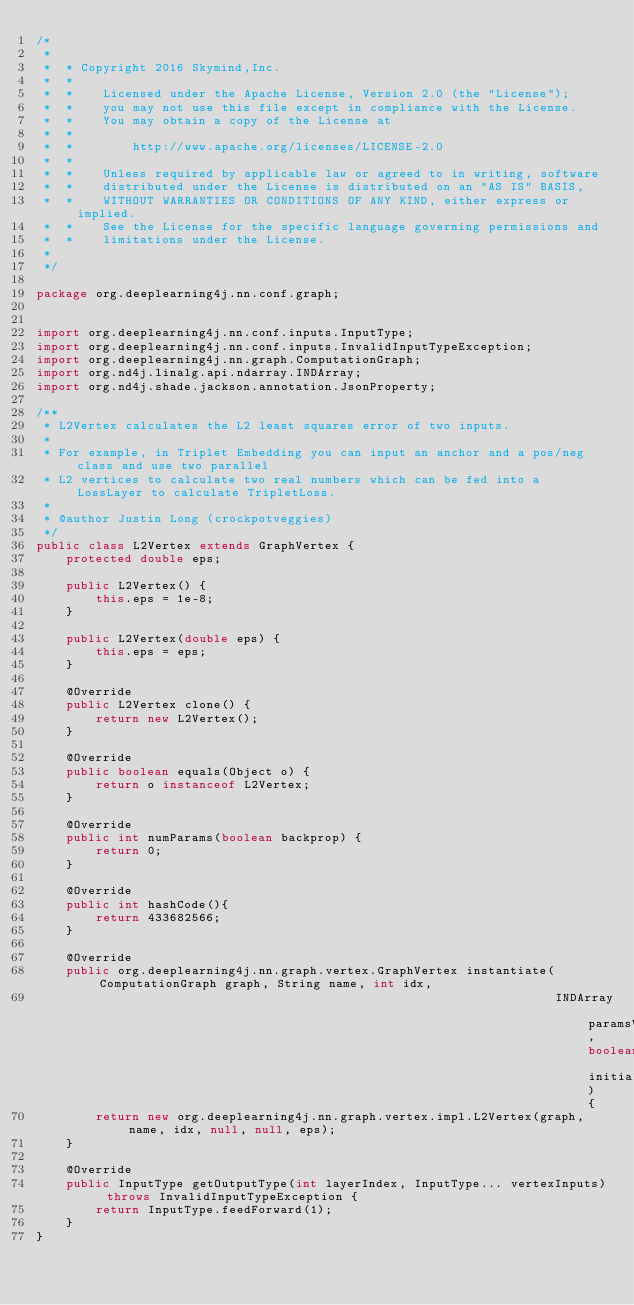Convert code to text. <code><loc_0><loc_0><loc_500><loc_500><_Java_>/*
 *
 *  * Copyright 2016 Skymind,Inc.
 *  *
 *  *    Licensed under the Apache License, Version 2.0 (the "License");
 *  *    you may not use this file except in compliance with the License.
 *  *    You may obtain a copy of the License at
 *  *
 *  *        http://www.apache.org/licenses/LICENSE-2.0
 *  *
 *  *    Unless required by applicable law or agreed to in writing, software
 *  *    distributed under the License is distributed on an "AS IS" BASIS,
 *  *    WITHOUT WARRANTIES OR CONDITIONS OF ANY KIND, either express or implied.
 *  *    See the License for the specific language governing permissions and
 *  *    limitations under the License.
 *
 */

package org.deeplearning4j.nn.conf.graph;


import org.deeplearning4j.nn.conf.inputs.InputType;
import org.deeplearning4j.nn.conf.inputs.InvalidInputTypeException;
import org.deeplearning4j.nn.graph.ComputationGraph;
import org.nd4j.linalg.api.ndarray.INDArray;
import org.nd4j.shade.jackson.annotation.JsonProperty;

/**
 * L2Vertex calculates the L2 least squares error of two inputs.
 *
 * For example, in Triplet Embedding you can input an anchor and a pos/neg class and use two parallel
 * L2 vertices to calculate two real numbers which can be fed into a LossLayer to calculate TripletLoss.
 *
 * @author Justin Long (crockpotveggies)
 */
public class L2Vertex extends GraphVertex {
    protected double eps;

    public L2Vertex() {
        this.eps = 1e-8;
    }

    public L2Vertex(double eps) {
        this.eps = eps;
    }

    @Override
    public L2Vertex clone() {
        return new L2Vertex();
    }

    @Override
    public boolean equals(Object o) {
        return o instanceof L2Vertex;
    }

    @Override
    public int numParams(boolean backprop) {
        return 0;
    }

    @Override
    public int hashCode(){
        return 433682566;
    }

    @Override
    public org.deeplearning4j.nn.graph.vertex.GraphVertex instantiate(ComputationGraph graph, String name, int idx,
                                                                      INDArray paramsView, boolean initializeParams) {
        return new org.deeplearning4j.nn.graph.vertex.impl.L2Vertex(graph, name, idx, null, null, eps);
    }

    @Override
    public InputType getOutputType(int layerIndex, InputType... vertexInputs) throws InvalidInputTypeException {
        return InputType.feedForward(1);
    }
}
</code> 